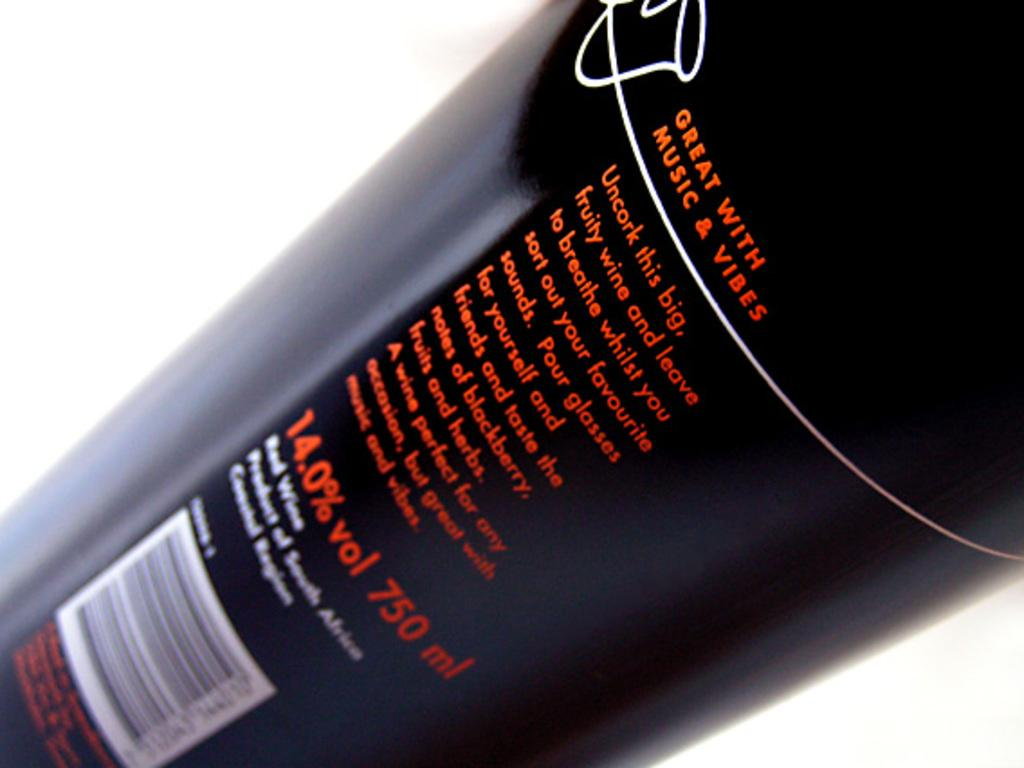<image>
Give a short and clear explanation of the subsequent image. A bottle of fruity wine that says you should uncork it and allow it to breath. 